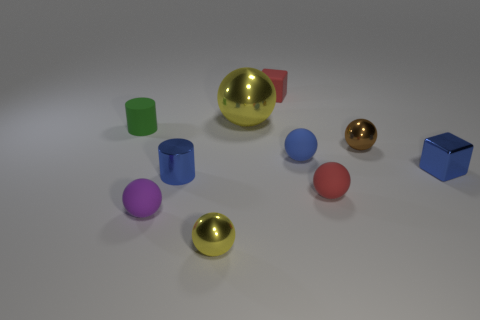Subtract all tiny purple balls. How many balls are left? 5 Subtract all cyan cylinders. How many yellow balls are left? 2 Subtract all brown spheres. How many spheres are left? 5 Subtract 2 cubes. How many cubes are left? 0 Subtract all cubes. How many objects are left? 8 Subtract all small green objects. Subtract all metallic spheres. How many objects are left? 6 Add 9 brown metal things. How many brown metal things are left? 10 Add 4 tiny blue balls. How many tiny blue balls exist? 5 Subtract 0 yellow cylinders. How many objects are left? 10 Subtract all yellow blocks. Subtract all gray spheres. How many blocks are left? 2 